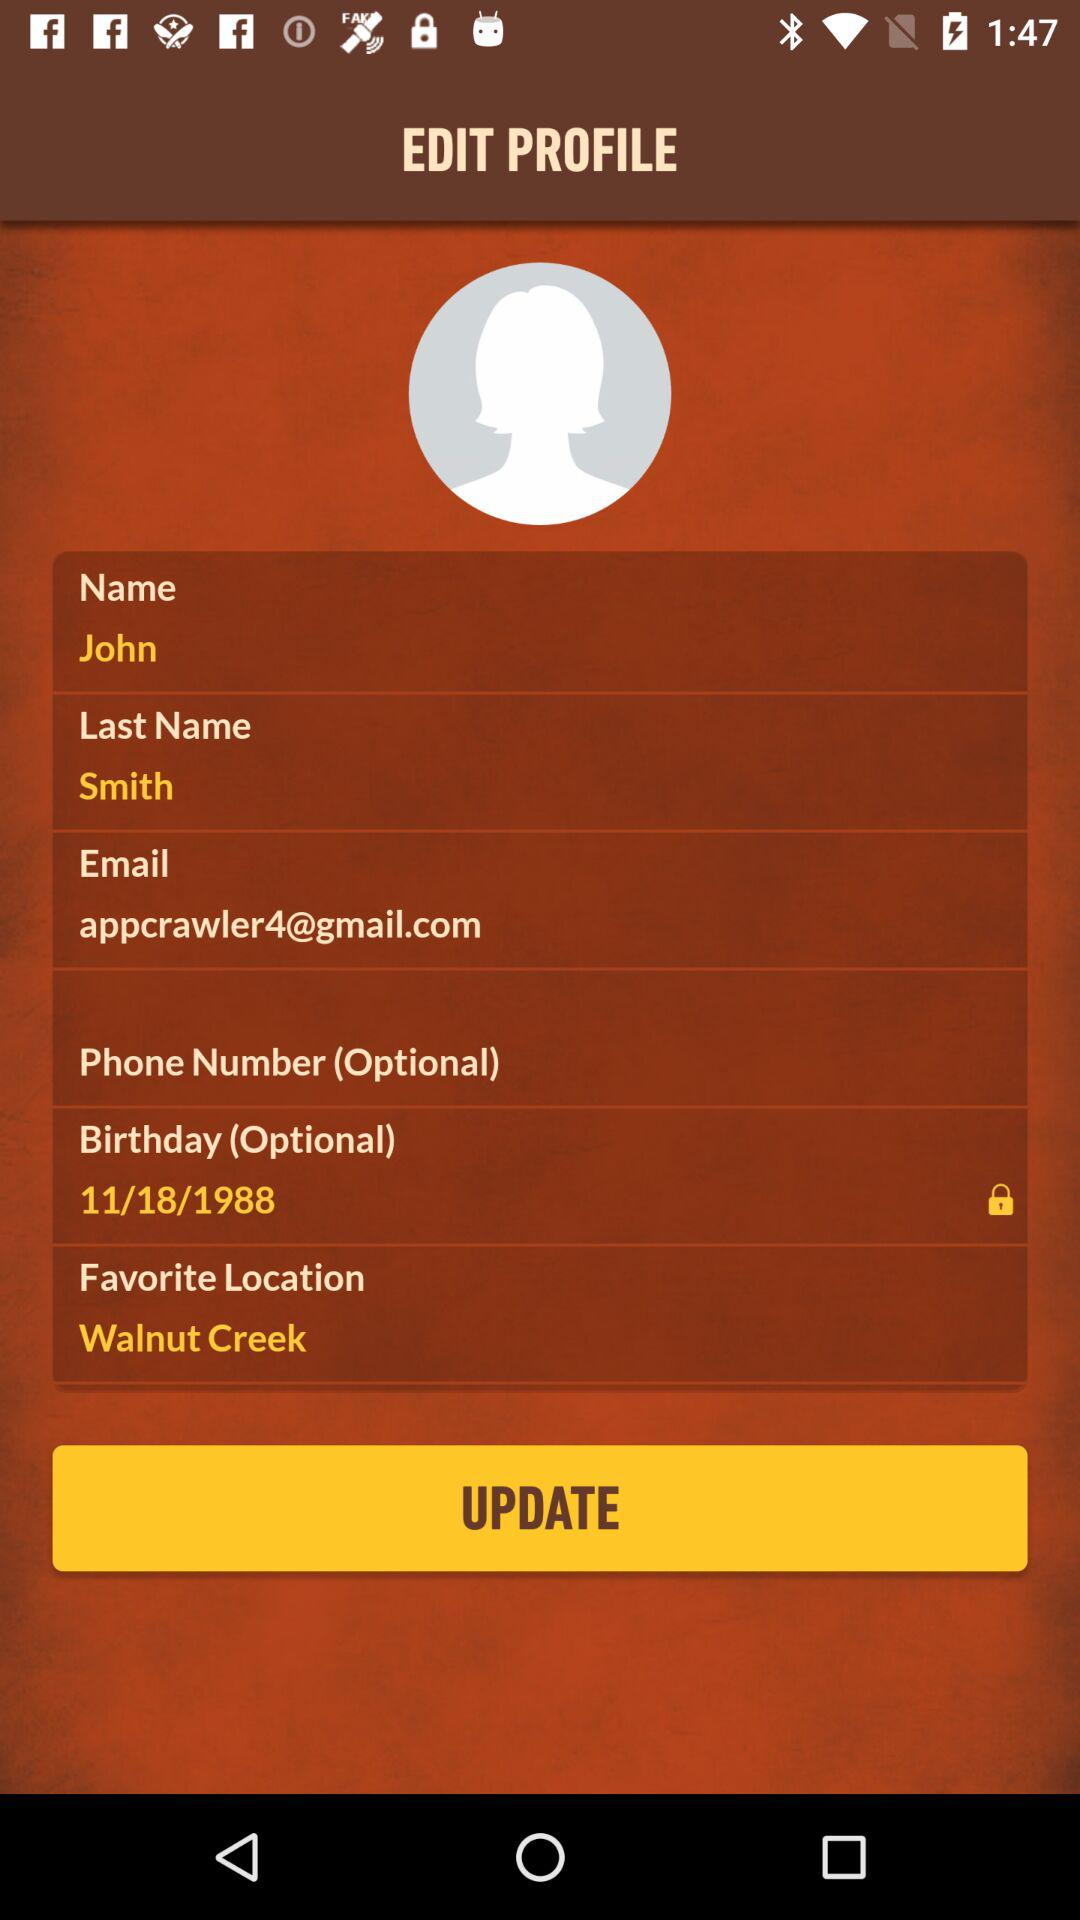What is the name of the person? The name is John Smith. 